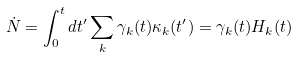<formula> <loc_0><loc_0><loc_500><loc_500>\dot { N } = \int ^ { t } _ { 0 } d t ^ { \prime } \sum _ { k } \gamma _ { k } ( t ) \kappa _ { k } ( t ^ { \prime } ) = \gamma _ { k } ( t ) H _ { k } ( t )</formula> 